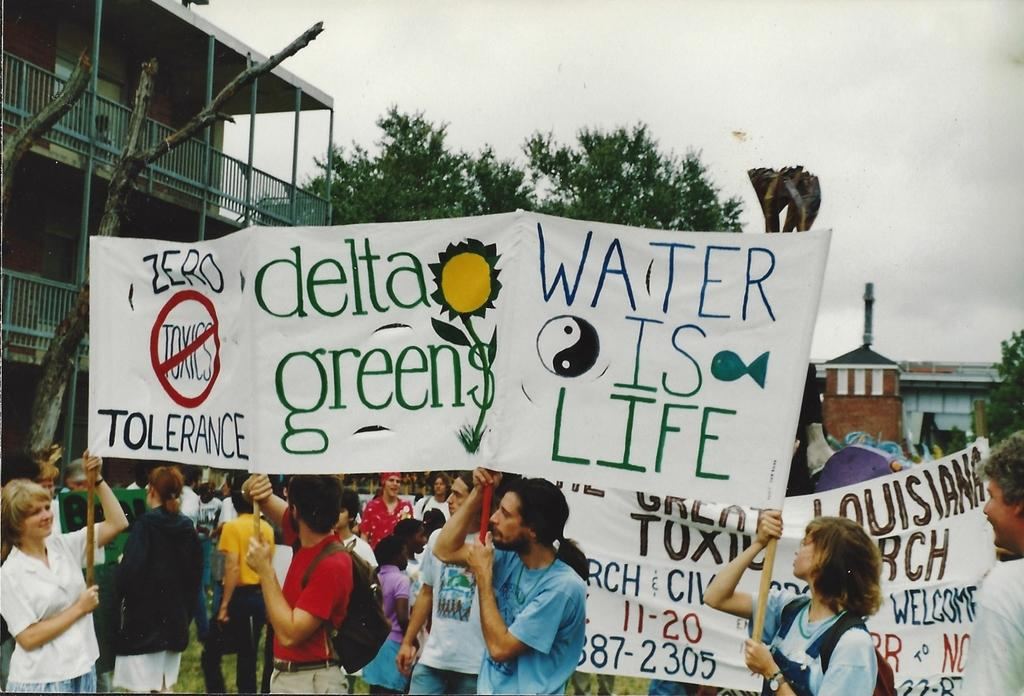What are the persons in the image doing? The persons in the image are standing and holding boards in their hands. What can be seen in the background of the image? There are trees, buildings, and the sky visible in the background of the image. What type of pleasure can be seen being enjoyed by the persons in the image? There is no indication of pleasure being enjoyed by the persons in the image; they are simply holding boards in their hands. What position are the persons in the image standing in? The provided facts do not specify the position or stance of the persons in the image. 